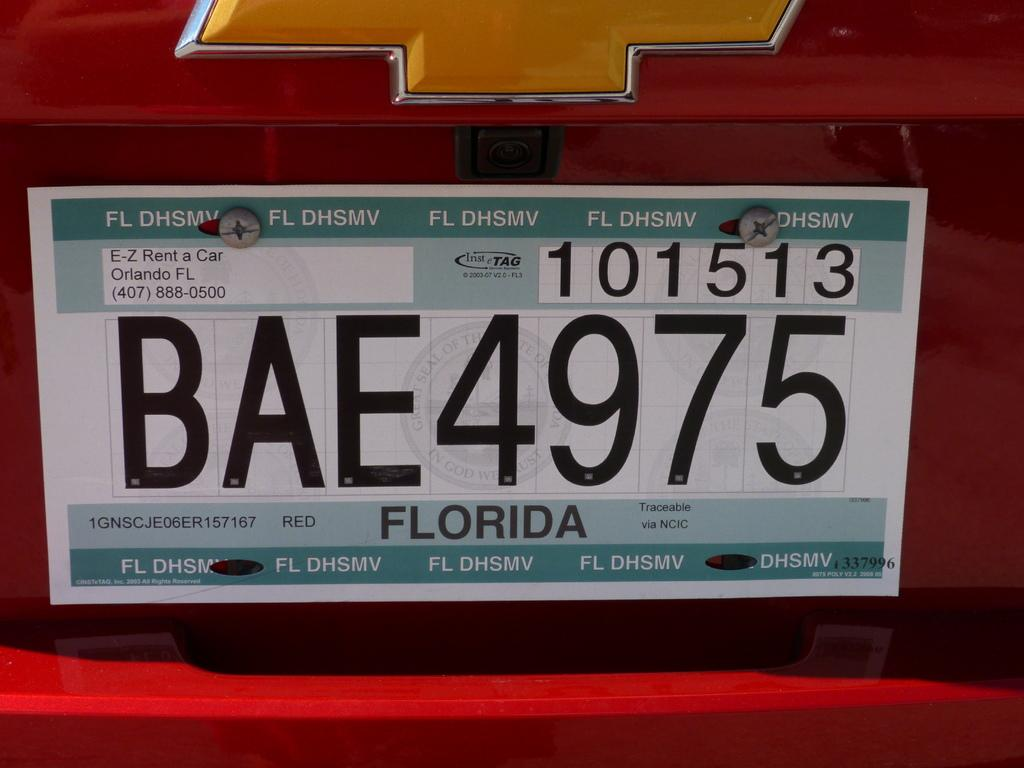<image>
Summarize the visual content of the image. the letters BAE that are on a license plate 